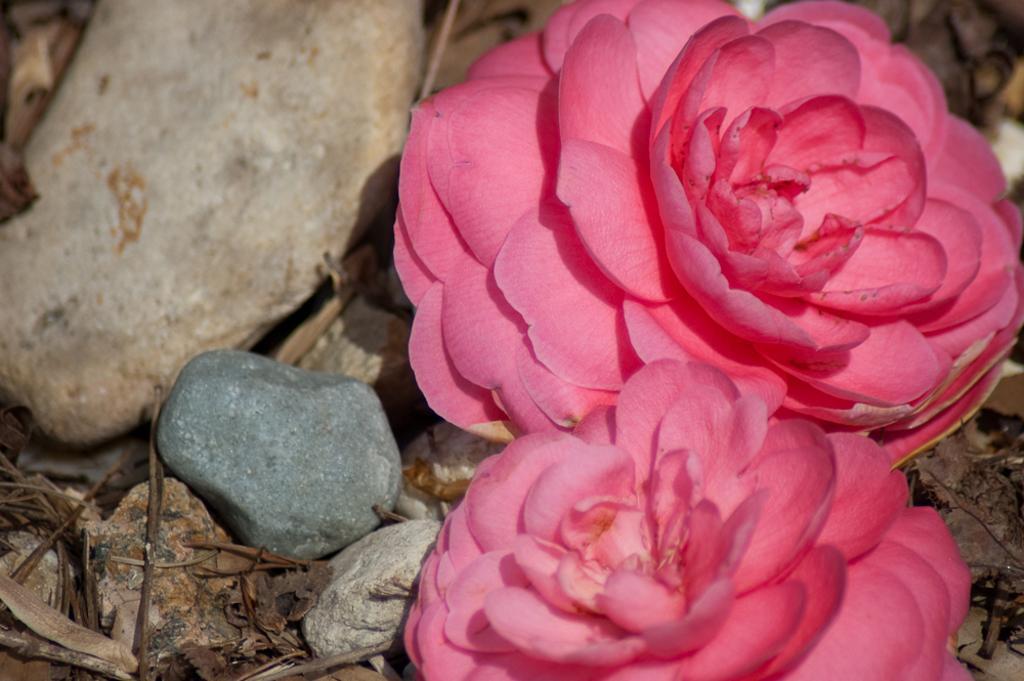How would you summarize this image in a sentence or two? On the right side of the image we can see flowers, and also we can find few stones. 